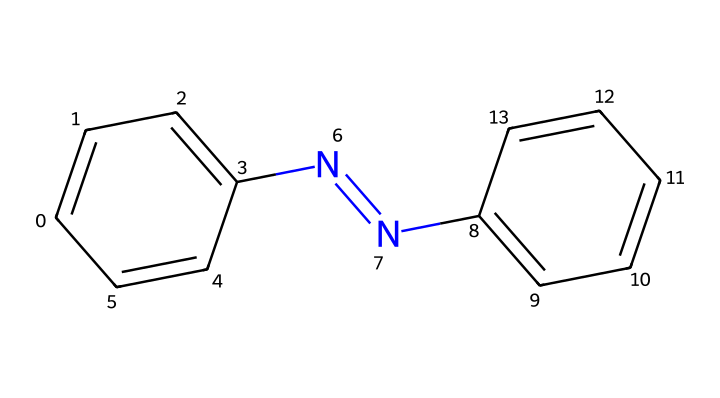What is the name of this chemical? The structure corresponds to azobenzene, as indicated by the two benzene rings connected by a nitrogen-nitrogen double bond (N=N).
Answer: azobenzene How many carbon atoms are in azobenzene? The two benzene rings contribute a total of twelve carbon atoms (each ring contains six carbons).
Answer: twelve What type of bond exists between the two nitrogen atoms in azobenzene? The two nitrogen atoms are connected by a double bond (N=N), which is a characteristic feature of azobenzene.
Answer: double bond What is one primary application of azobenzene in textiles? Azobenzene is used as a photochrome, allowing it to change color when exposed to light, which can be advantageous in textile dyes.
Answer: photochrome What happens to azobenzene upon UV light exposure? Upon UV light exposure, azobenzene undergoes a structural change (isomerization) from the trans form to the cis form, resulting in a change in physical properties like solubility and color.
Answer: isomerization How does the photoisomerization of azobenzene impact its use in textiles? The ability to switch between isomers upon light exposure allows textiles dyed with azobenzene to exhibit dynamic color changes, leading to potential applications in smart textiles.
Answer: dynamic color changes What is the molecular formula of azobenzene? The molecular formula can be derived from the constituent atoms: C12H10N2 (12 carbons, 10 hydrogens, 2 nitrogens).
Answer: C12H10N2 